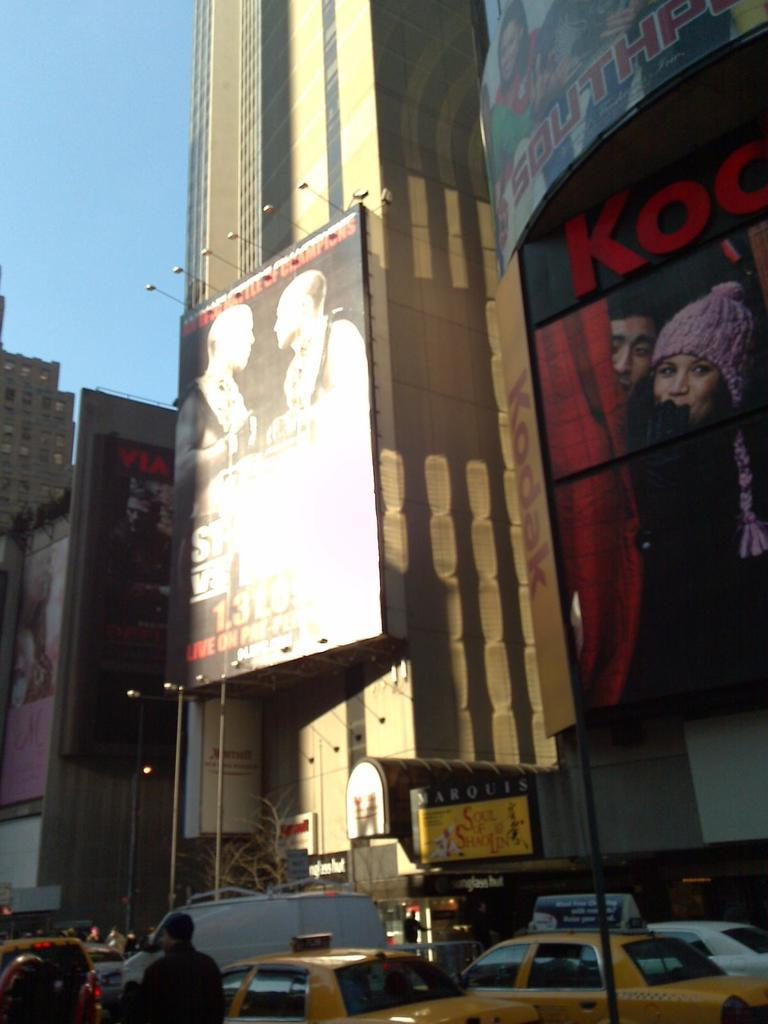What type of structures can be seen in the image? There are buildings in the image. What else is present on the buildings in the image? There are hoardings with text and human pictures on the buildings. What type of vehicles are visible in the image? There are cars in the image. Can you describe the man in the image? There is a man in the image. Are the hoardings illuminated in the image? Yes, there are lights on the hoardings in the image. What color is the sky in the image? The sky is blue in the image. Where is the goat located in the image? There is no goat present in the image. What type of zipper can be seen on the man's clothing in the image? There is no zipper visible on the man's clothing in the image. 